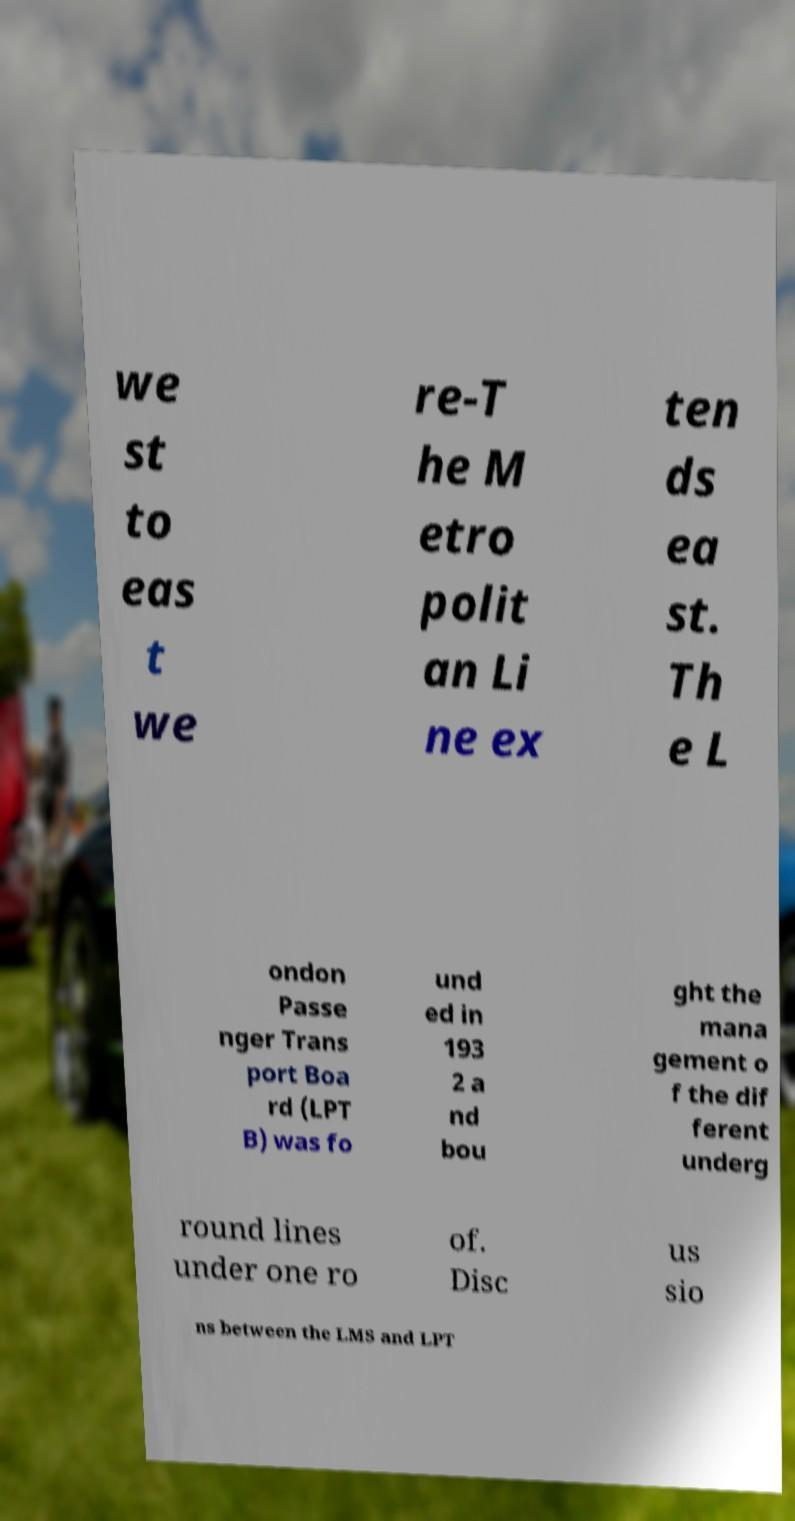For documentation purposes, I need the text within this image transcribed. Could you provide that? we st to eas t we re-T he M etro polit an Li ne ex ten ds ea st. Th e L ondon Passe nger Trans port Boa rd (LPT B) was fo und ed in 193 2 a nd bou ght the mana gement o f the dif ferent underg round lines under one ro of. Disc us sio ns between the LMS and LPT 